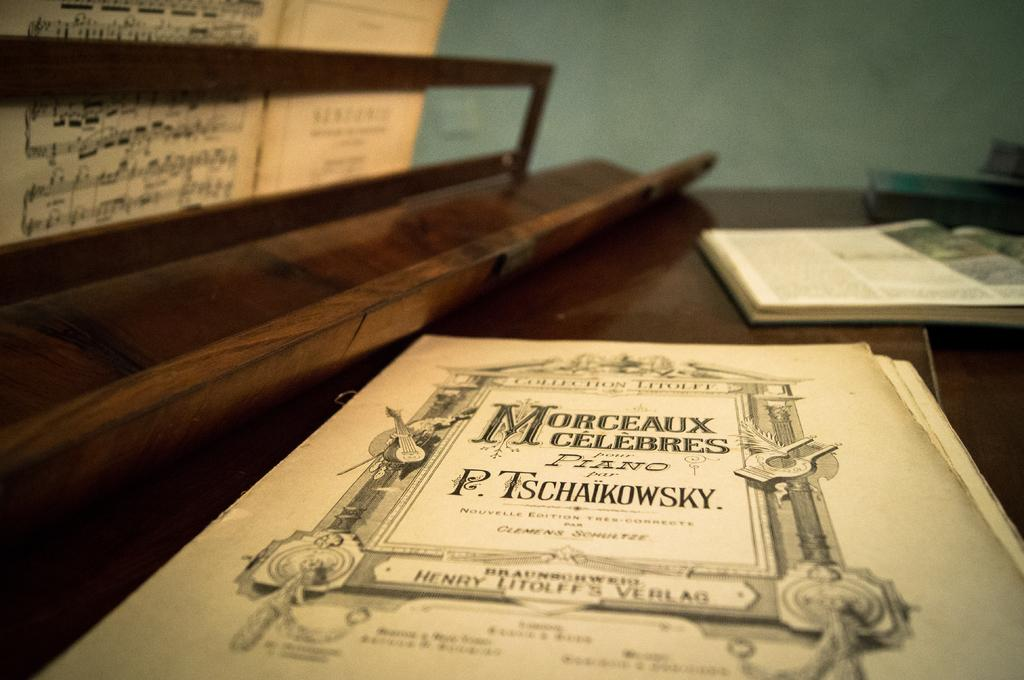<image>
Present a compact description of the photo's key features. Sheet music by Tschaikowsky is on top of a piano. 